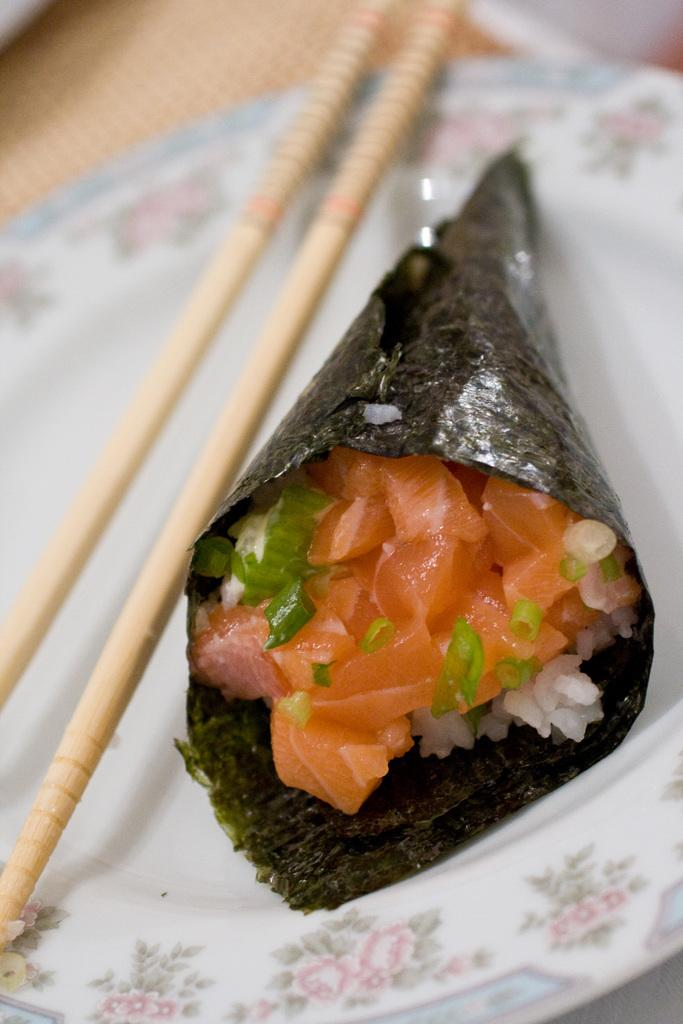What is present on the plate in the image? There is food in the image. What utensil is used to eat the food on the plate? There are chopsticks in the image. Can you describe the type of food on the plate? The provided facts do not specify the type of food on the plate. What type of machine is visible in the image? There is no machine present in the image. Is the food on the plate made of gold? The provided facts do not mention the material of the food on the plate. 